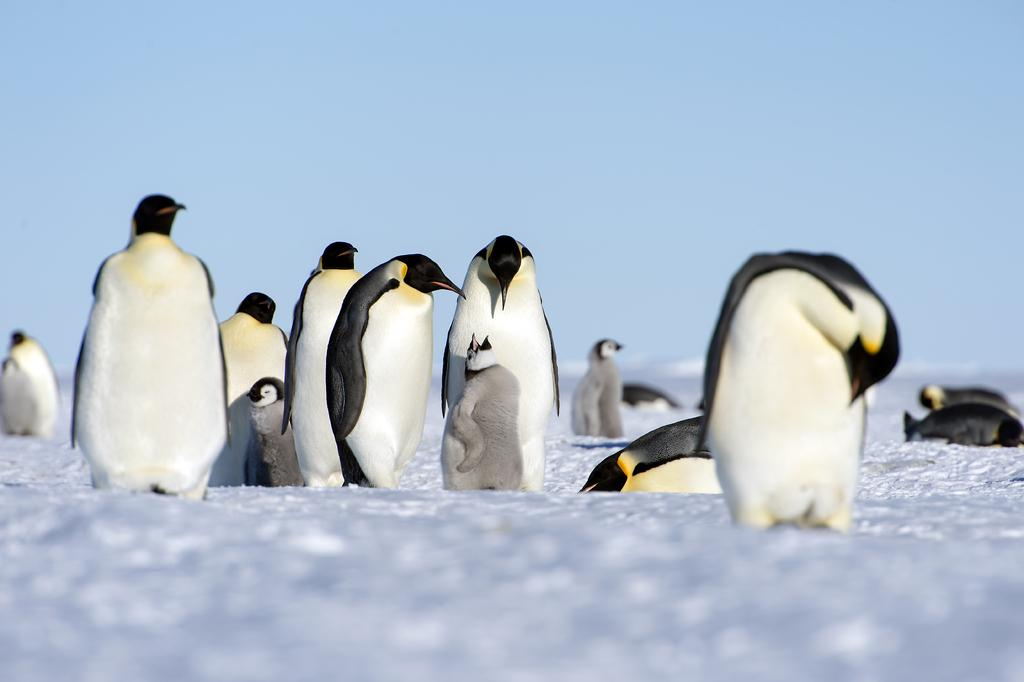What animals are present in the image? There are penguins in the image. Where are the penguins located? The penguins are on an iceberg. Can you describe the background of the image? The background of the image is blurred. What type of books can be seen in the image? There are no books present in the image; it features penguins on an iceberg. Is there a prison visible in the image? There is no prison present in the image. 